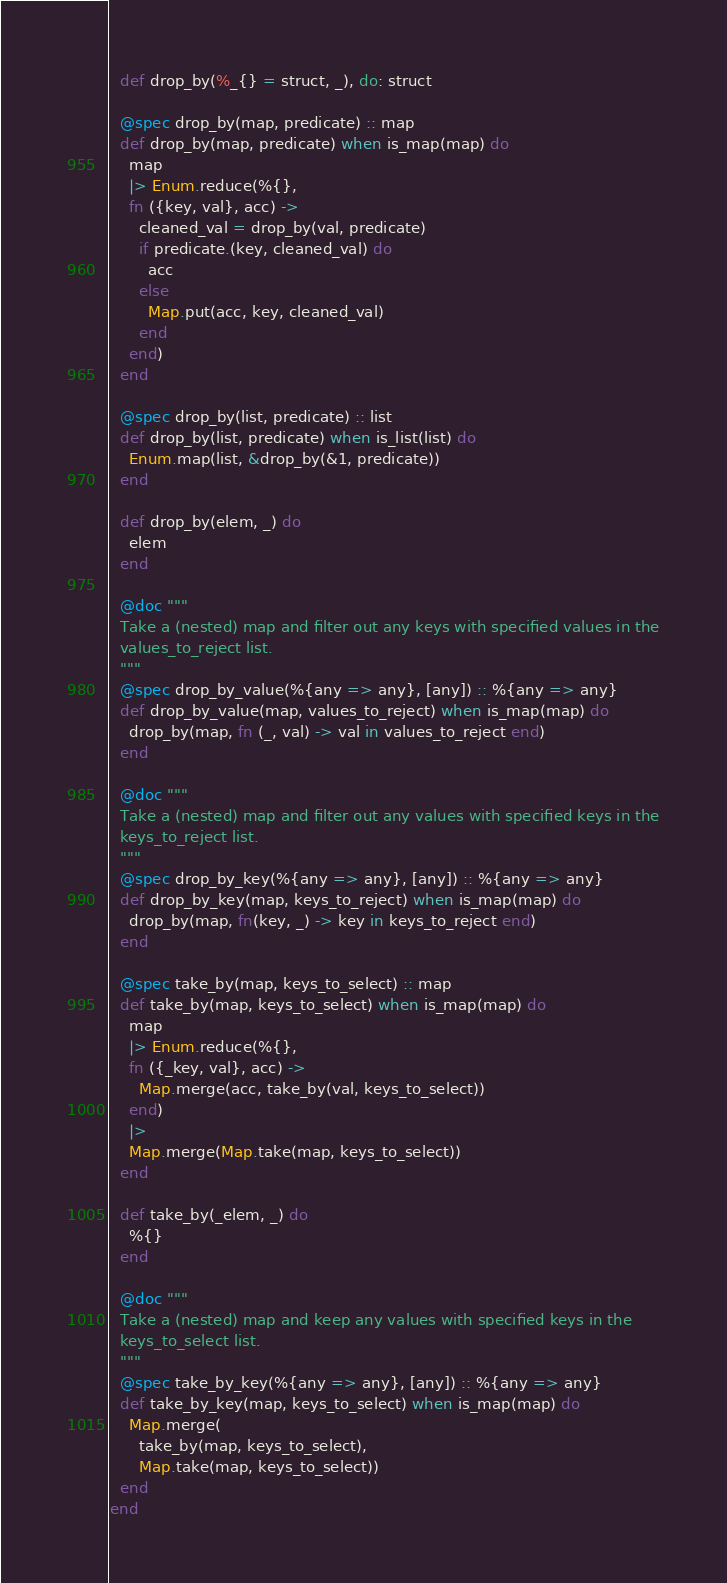Convert code to text. <code><loc_0><loc_0><loc_500><loc_500><_Elixir_>  def drop_by(%_{} = struct, _), do: struct

  @spec drop_by(map, predicate) :: map
  def drop_by(map, predicate) when is_map(map) do
    map
    |> Enum.reduce(%{},
    fn ({key, val}, acc) ->
      cleaned_val = drop_by(val, predicate)
      if predicate.(key, cleaned_val) do
        acc
      else
        Map.put(acc, key, cleaned_val)
      end
    end)
  end

  @spec drop_by(list, predicate) :: list
  def drop_by(list, predicate) when is_list(list) do
    Enum.map(list, &drop_by(&1, predicate))
  end

  def drop_by(elem, _) do
    elem
  end

  @doc """
  Take a (nested) map and filter out any keys with specified values in the
  values_to_reject list.
  """
  @spec drop_by_value(%{any => any}, [any]) :: %{any => any}
  def drop_by_value(map, values_to_reject) when is_map(map) do
    drop_by(map, fn (_, val) -> val in values_to_reject end)
  end

  @doc """
  Take a (nested) map and filter out any values with specified keys in the
  keys_to_reject list.
  """
  @spec drop_by_key(%{any => any}, [any]) :: %{any => any}
  def drop_by_key(map, keys_to_reject) when is_map(map) do
    drop_by(map, fn(key, _) -> key in keys_to_reject end)
  end

  @spec take_by(map, keys_to_select) :: map
  def take_by(map, keys_to_select) when is_map(map) do
    map
    |> Enum.reduce(%{},
    fn ({_key, val}, acc) ->
      Map.merge(acc, take_by(val, keys_to_select))
    end)
    |>
    Map.merge(Map.take(map, keys_to_select))
  end

  def take_by(_elem, _) do
    %{}
  end

  @doc """
  Take a (nested) map and keep any values with specified keys in the
  keys_to_select list.
  """
  @spec take_by_key(%{any => any}, [any]) :: %{any => any}
  def take_by_key(map, keys_to_select) when is_map(map) do
    Map.merge(
      take_by(map, keys_to_select),
      Map.take(map, keys_to_select))
  end
end
</code> 